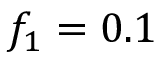Convert formula to latex. <formula><loc_0><loc_0><loc_500><loc_500>f _ { 1 } = 0 . 1</formula> 